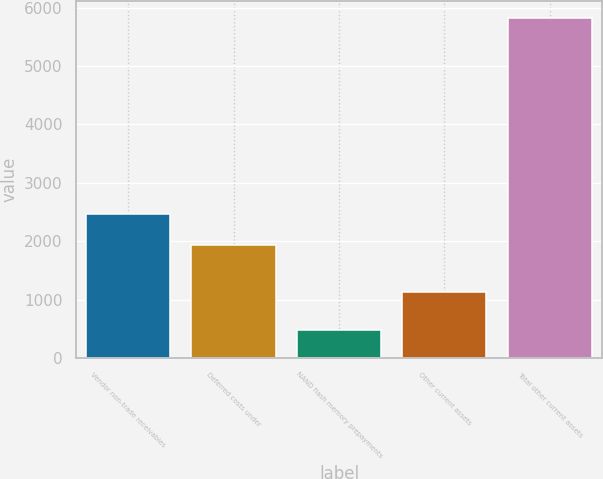Convert chart. <chart><loc_0><loc_0><loc_500><loc_500><bar_chart><fcel>Vendor non-trade receivables<fcel>Deferred costs under<fcel>NAND flash memory prepayments<fcel>Other current assets<fcel>Total other current assets<nl><fcel>2465.7<fcel>1931<fcel>475<fcel>1134<fcel>5822<nl></chart> 